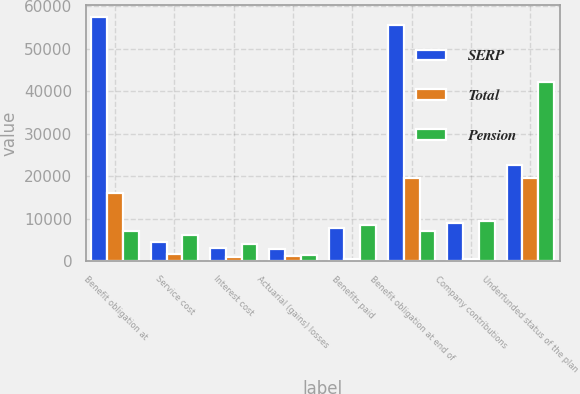Convert chart. <chart><loc_0><loc_0><loc_500><loc_500><stacked_bar_chart><ecel><fcel>Benefit obligation at<fcel>Service cost<fcel>Interest cost<fcel>Actuarial (gains) losses<fcel>Benefits paid<fcel>Benefit obligation at end of<fcel>Company contributions<fcel>Underfunded status of the plan<nl><fcel>SERP<fcel>57366<fcel>4555<fcel>3093<fcel>2802<fcel>7924<fcel>55502<fcel>8936<fcel>22677<nl><fcel>Total<fcel>16135<fcel>1739<fcel>965<fcel>1253<fcel>580<fcel>19512<fcel>580<fcel>19512<nl><fcel>Pension<fcel>7109<fcel>6294<fcel>4058<fcel>1549<fcel>8504<fcel>7109<fcel>9516<fcel>42189<nl></chart> 